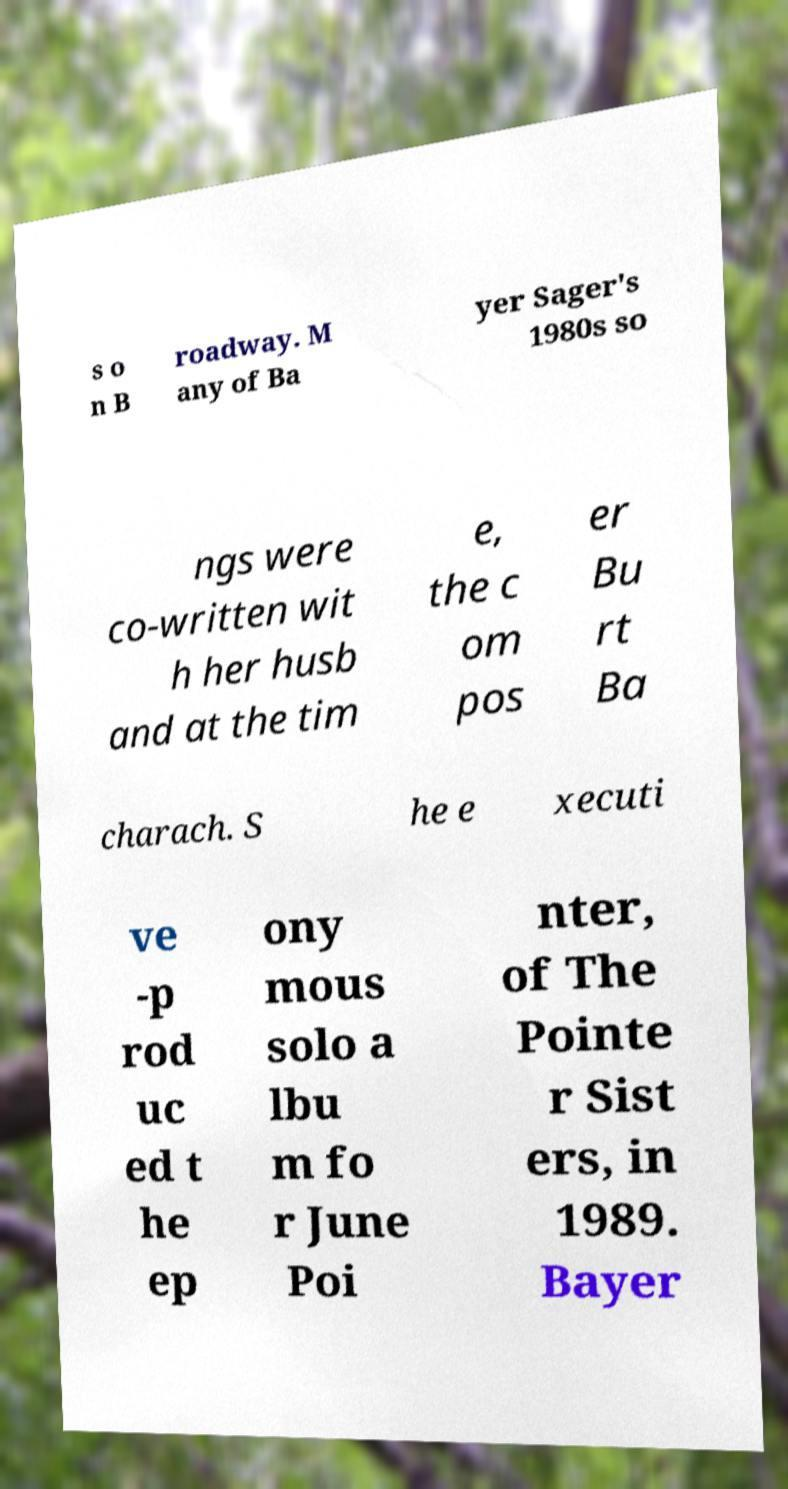What messages or text are displayed in this image? I need them in a readable, typed format. s o n B roadway. M any of Ba yer Sager's 1980s so ngs were co-written wit h her husb and at the tim e, the c om pos er Bu rt Ba charach. S he e xecuti ve -p rod uc ed t he ep ony mous solo a lbu m fo r June Poi nter, of The Pointe r Sist ers, in 1989. Bayer 